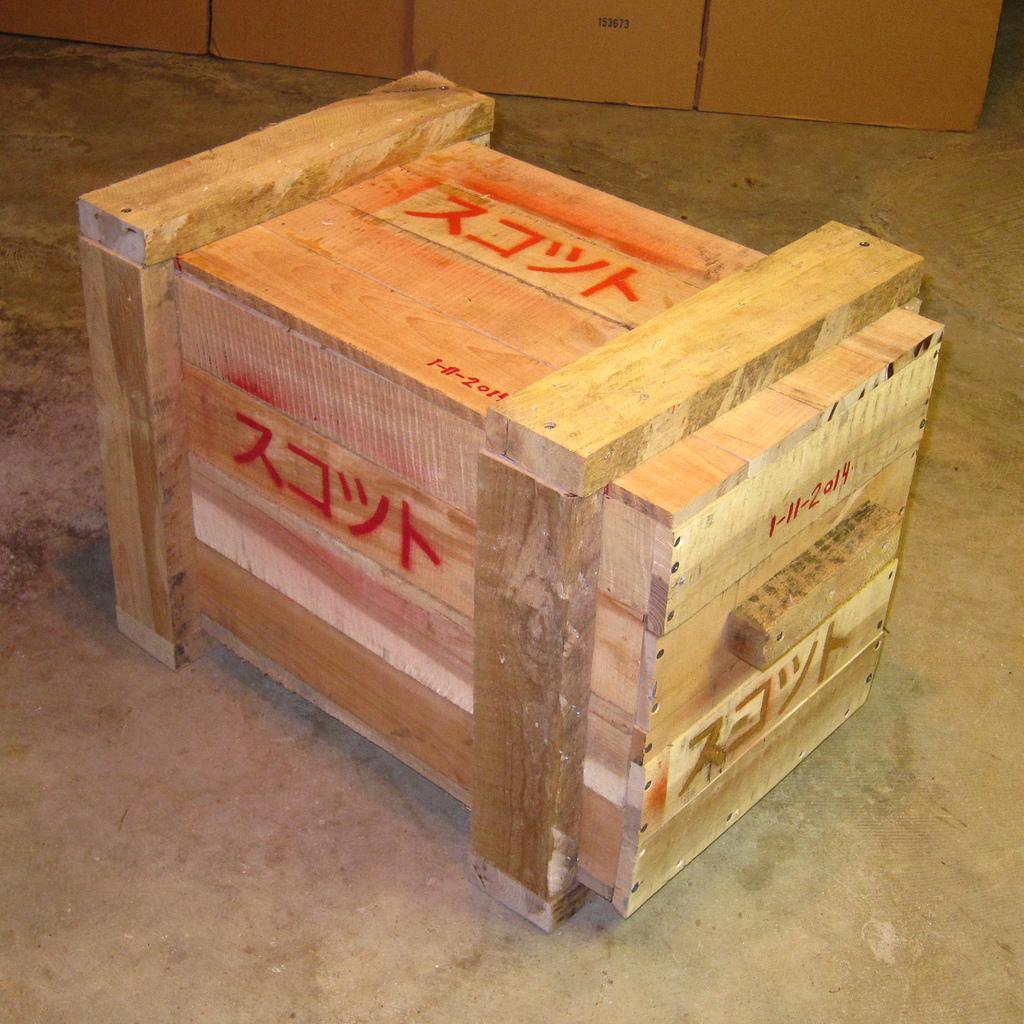Please provide a concise description of this image. In the foreground of this picture, there is a crate on the ground. In the background, there are cardboard boxes. 